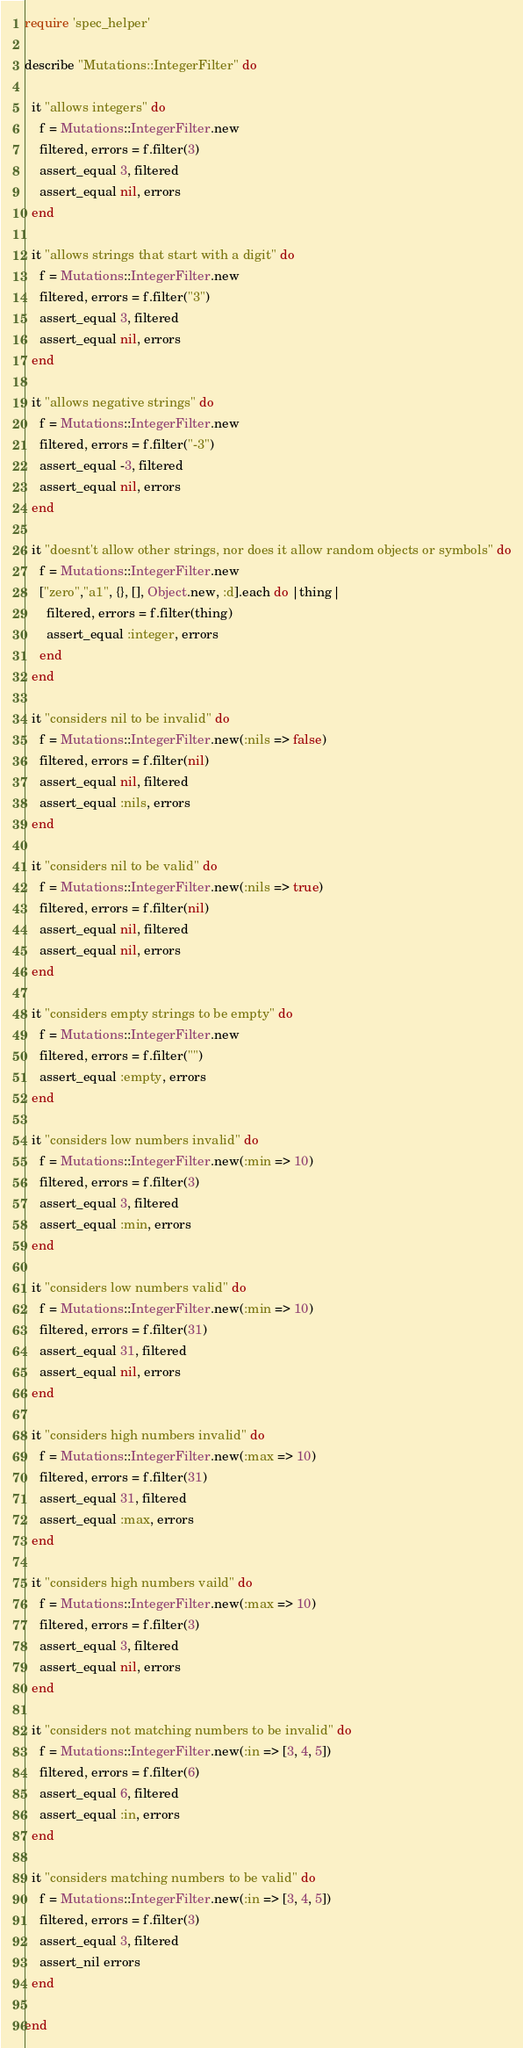Convert code to text. <code><loc_0><loc_0><loc_500><loc_500><_Ruby_>require 'spec_helper'

describe "Mutations::IntegerFilter" do

  it "allows integers" do
    f = Mutations::IntegerFilter.new
    filtered, errors = f.filter(3)
    assert_equal 3, filtered
    assert_equal nil, errors
  end

  it "allows strings that start with a digit" do
    f = Mutations::IntegerFilter.new
    filtered, errors = f.filter("3")
    assert_equal 3, filtered
    assert_equal nil, errors
  end

  it "allows negative strings" do
    f = Mutations::IntegerFilter.new
    filtered, errors = f.filter("-3")
    assert_equal -3, filtered
    assert_equal nil, errors
  end

  it "doesnt't allow other strings, nor does it allow random objects or symbols" do
    f = Mutations::IntegerFilter.new
    ["zero","a1", {}, [], Object.new, :d].each do |thing|
      filtered, errors = f.filter(thing)
      assert_equal :integer, errors
    end
  end

  it "considers nil to be invalid" do
    f = Mutations::IntegerFilter.new(:nils => false)
    filtered, errors = f.filter(nil)
    assert_equal nil, filtered
    assert_equal :nils, errors
  end

  it "considers nil to be valid" do
    f = Mutations::IntegerFilter.new(:nils => true)
    filtered, errors = f.filter(nil)
    assert_equal nil, filtered
    assert_equal nil, errors
  end
  
  it "considers empty strings to be empty" do
    f = Mutations::IntegerFilter.new
    filtered, errors = f.filter("")
    assert_equal :empty, errors
  end

  it "considers low numbers invalid" do
    f = Mutations::IntegerFilter.new(:min => 10)
    filtered, errors = f.filter(3)
    assert_equal 3, filtered
    assert_equal :min, errors
  end

  it "considers low numbers valid" do
    f = Mutations::IntegerFilter.new(:min => 10)
    filtered, errors = f.filter(31)
    assert_equal 31, filtered
    assert_equal nil, errors
  end

  it "considers high numbers invalid" do
    f = Mutations::IntegerFilter.new(:max => 10)
    filtered, errors = f.filter(31)
    assert_equal 31, filtered
    assert_equal :max, errors
  end

  it "considers high numbers vaild" do
    f = Mutations::IntegerFilter.new(:max => 10)
    filtered, errors = f.filter(3)
    assert_equal 3, filtered
    assert_equal nil, errors
  end

  it "considers not matching numbers to be invalid" do
    f = Mutations::IntegerFilter.new(:in => [3, 4, 5])
    filtered, errors = f.filter(6)
    assert_equal 6, filtered
    assert_equal :in, errors
  end

  it "considers matching numbers to be valid" do
    f = Mutations::IntegerFilter.new(:in => [3, 4, 5])
    filtered, errors = f.filter(3)
    assert_equal 3, filtered
    assert_nil errors
  end

end
</code> 